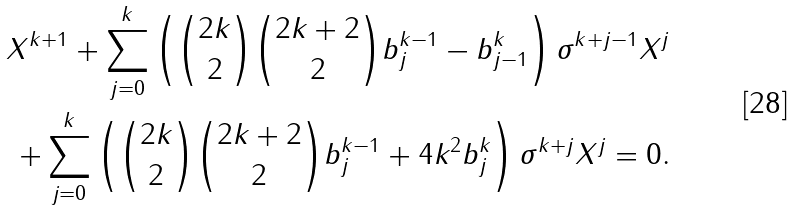Convert formula to latex. <formula><loc_0><loc_0><loc_500><loc_500>X ^ { k + 1 } + \sum _ { j = 0 } ^ { k } \left ( { 2 k \choose 2 } { 2 k + 2 \choose 2 } b _ { j } ^ { k - 1 } - b ^ { k } _ { j - 1 } \right ) \sigma ^ { k + j - 1 } X ^ { j } \\ + \sum _ { j = 0 } ^ { k } \left ( { 2 k \choose 2 } { 2 k + 2 \choose 2 } b _ { j } ^ { k - 1 } + 4 k ^ { 2 } b _ { j } ^ { k } \right ) \sigma ^ { k + j } X ^ { j } = 0 . \\</formula> 